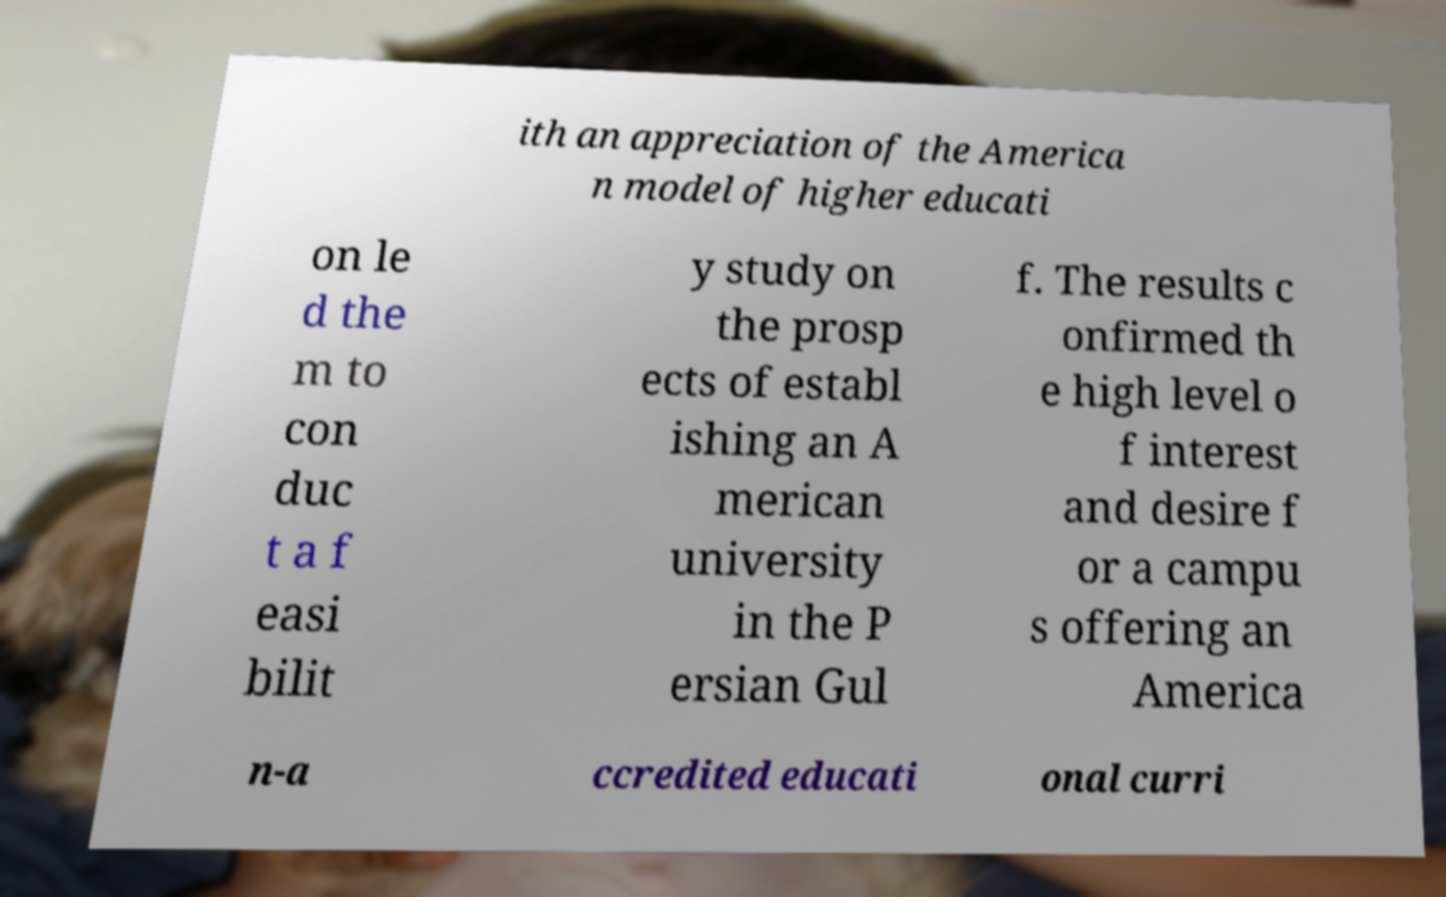Can you accurately transcribe the text from the provided image for me? ith an appreciation of the America n model of higher educati on le d the m to con duc t a f easi bilit y study on the prosp ects of establ ishing an A merican university in the P ersian Gul f. The results c onfirmed th e high level o f interest and desire f or a campu s offering an America n-a ccredited educati onal curri 